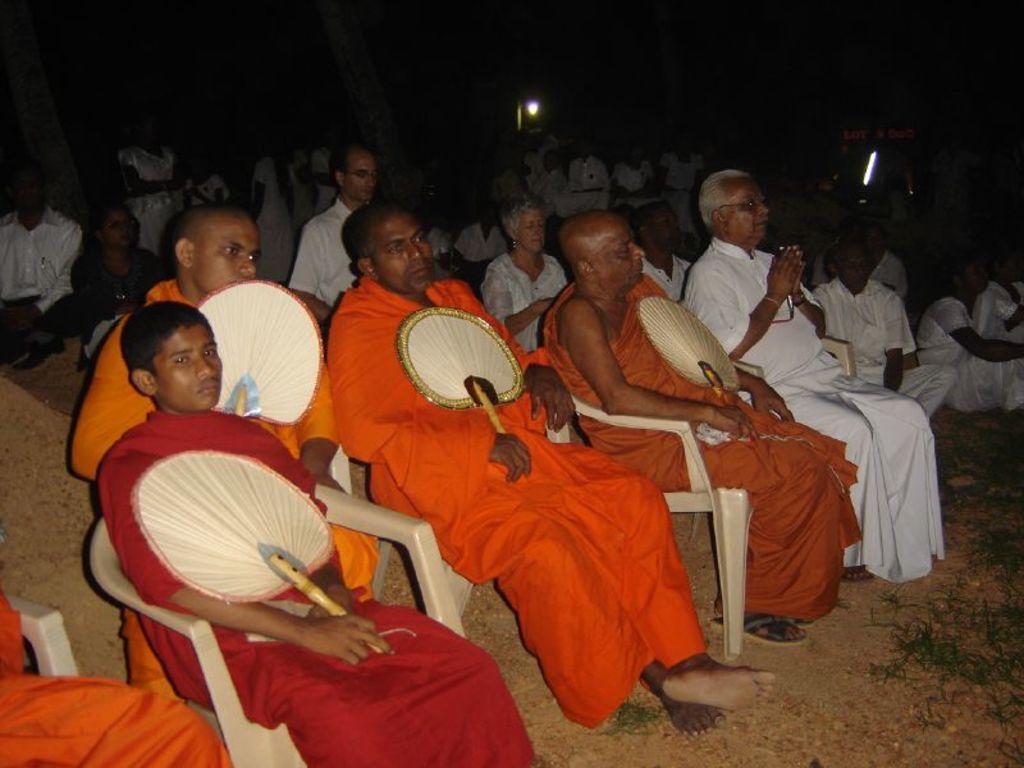Describe this image in one or two sentences. In this image there are group of people sitting on the chairs and holding fans , hand in the background there are group of people , lights. 